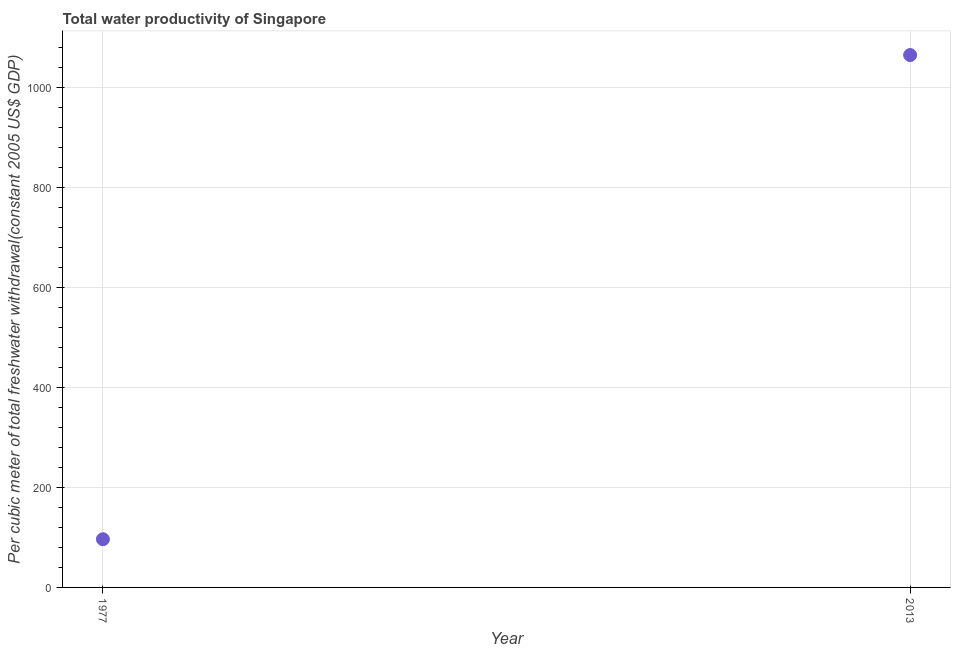What is the total water productivity in 2013?
Keep it short and to the point. 1065.38. Across all years, what is the maximum total water productivity?
Provide a succinct answer. 1065.38. Across all years, what is the minimum total water productivity?
Make the answer very short. 96.44. In which year was the total water productivity maximum?
Make the answer very short. 2013. In which year was the total water productivity minimum?
Your answer should be very brief. 1977. What is the sum of the total water productivity?
Ensure brevity in your answer.  1161.81. What is the difference between the total water productivity in 1977 and 2013?
Your response must be concise. -968.94. What is the average total water productivity per year?
Your answer should be very brief. 580.91. What is the median total water productivity?
Make the answer very short. 580.91. What is the ratio of the total water productivity in 1977 to that in 2013?
Offer a very short reply. 0.09. How many dotlines are there?
Provide a succinct answer. 1. How many years are there in the graph?
Provide a succinct answer. 2. What is the difference between two consecutive major ticks on the Y-axis?
Offer a terse response. 200. Does the graph contain grids?
Provide a short and direct response. Yes. What is the title of the graph?
Your response must be concise. Total water productivity of Singapore. What is the label or title of the Y-axis?
Your answer should be compact. Per cubic meter of total freshwater withdrawal(constant 2005 US$ GDP). What is the Per cubic meter of total freshwater withdrawal(constant 2005 US$ GDP) in 1977?
Keep it short and to the point. 96.44. What is the Per cubic meter of total freshwater withdrawal(constant 2005 US$ GDP) in 2013?
Provide a succinct answer. 1065.38. What is the difference between the Per cubic meter of total freshwater withdrawal(constant 2005 US$ GDP) in 1977 and 2013?
Offer a terse response. -968.94. What is the ratio of the Per cubic meter of total freshwater withdrawal(constant 2005 US$ GDP) in 1977 to that in 2013?
Provide a short and direct response. 0.09. 